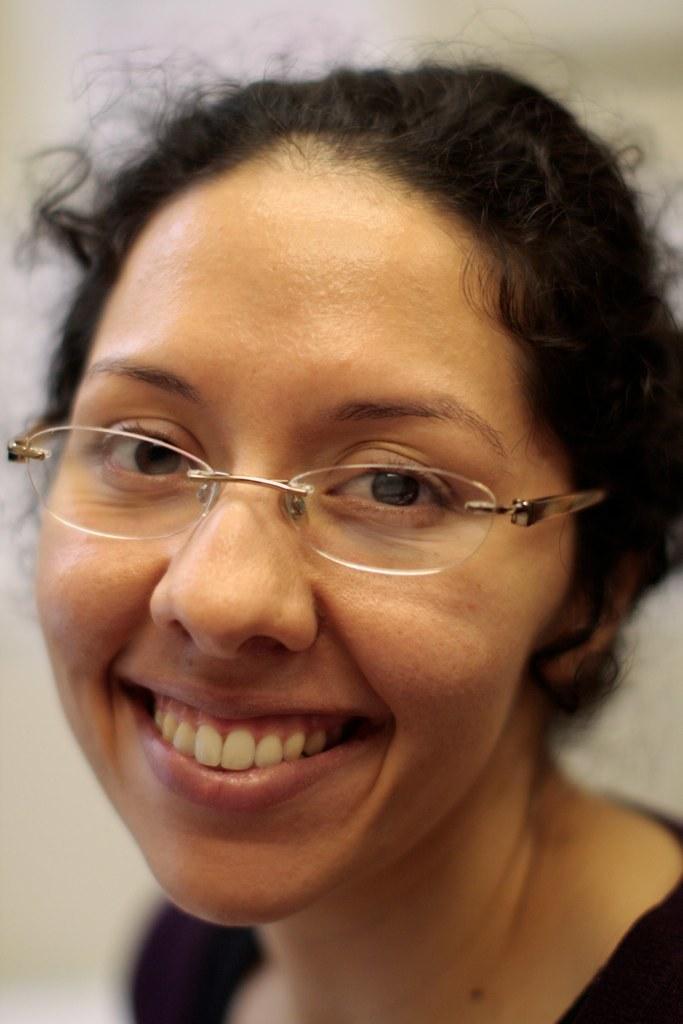How would you summarize this image in a sentence or two? This image consists of a woman wearing black dress and spectacles. In the background, there is a wall. 